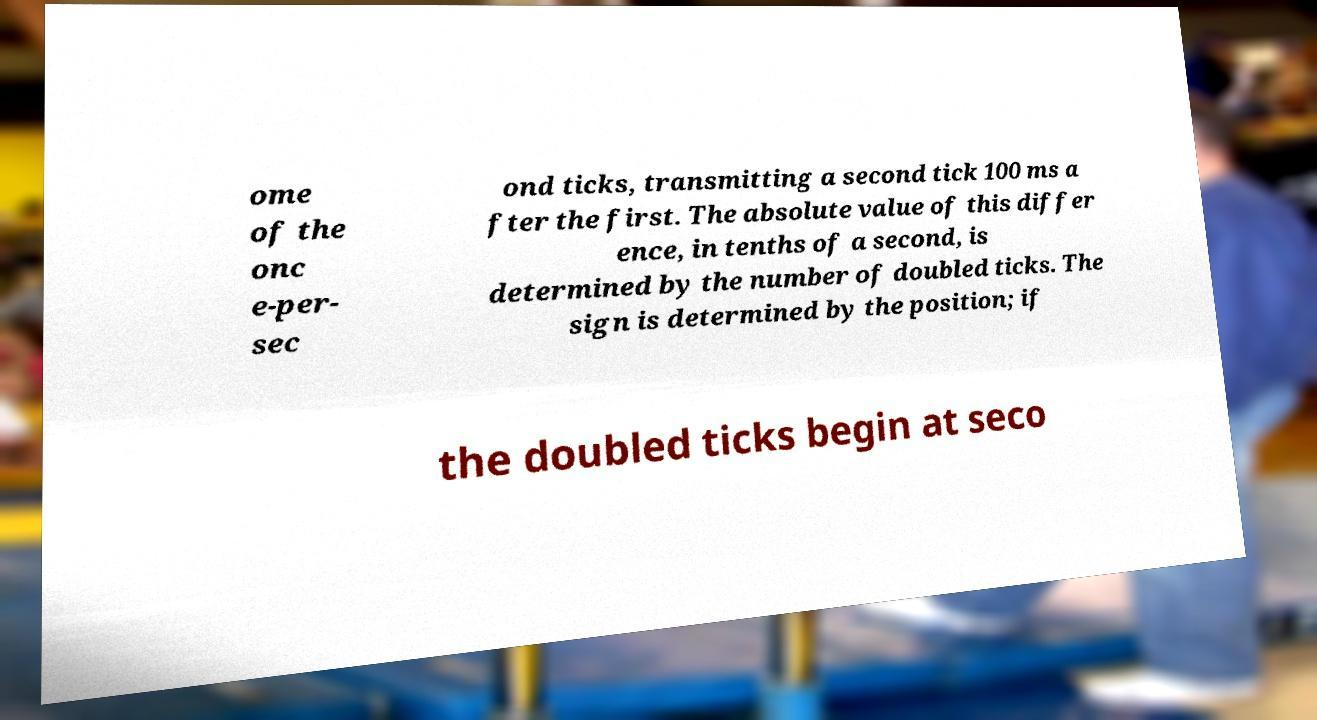Can you read and provide the text displayed in the image?This photo seems to have some interesting text. Can you extract and type it out for me? ome of the onc e-per- sec ond ticks, transmitting a second tick 100 ms a fter the first. The absolute value of this differ ence, in tenths of a second, is determined by the number of doubled ticks. The sign is determined by the position; if the doubled ticks begin at seco 